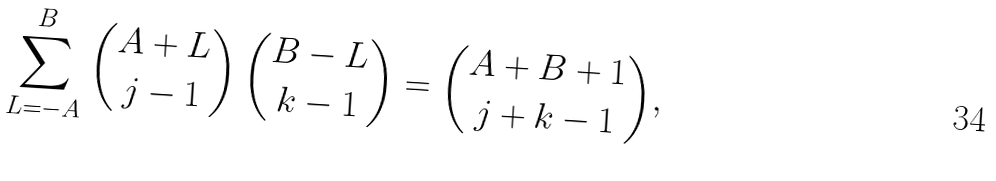Convert formula to latex. <formula><loc_0><loc_0><loc_500><loc_500>\sum _ { L = - A } ^ { B } { A + L \choose j - 1 } \, { B - L \choose k - 1 } = { A + B + 1 \choose j + k - 1 } ,</formula> 